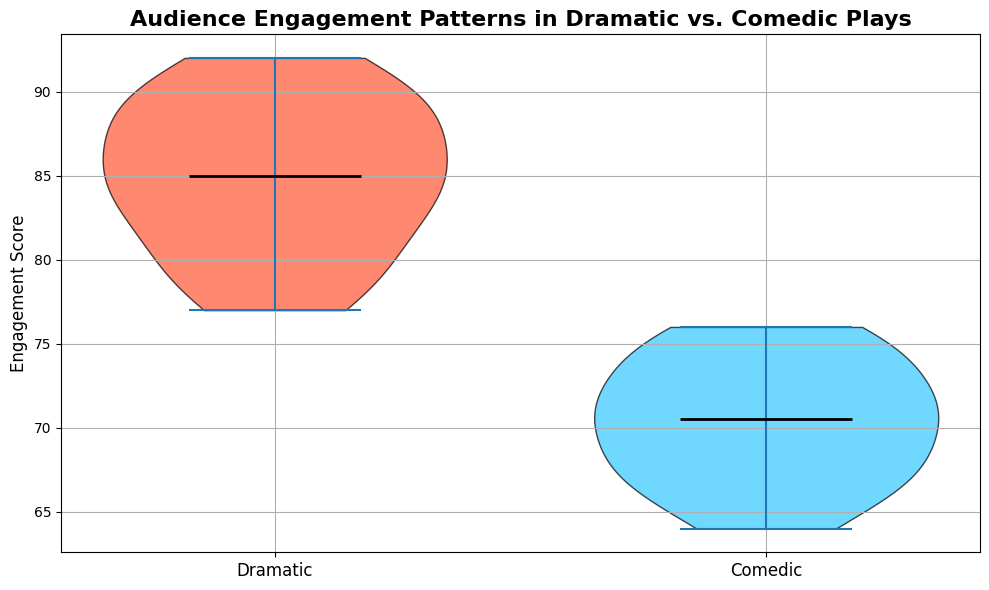Which play type has a higher median engagement score? The median is represented by the horizontal black line within the violin plot. The median for Dramatic plays is higher than the median for Comedic plays.
Answer: Dramatic What are the general ranges of engagement scores for both Dramatic and Comedic plays? The range can be observed from the lowest to the highest points within each violin. For Dramatic plays, it spans from about 77 to 92, while for Comedic plays, it spans from about 64 to 76.
Answer: Dramatic: 77-92, Comedic: 64-76 Are the engagement scores more spread out in Dramatic plays or Comedic plays? The spread can be determined by the width of each violin plot. The Dramatic plays' scores appear slightly more spread out as the violin is wider, indicating more variability within the scores.
Answer: Dramatic Which play type seems to have higher engagement scores overall? By visually comparing the position and density of the violins, we can see that the Dramatic plays tend to have higher engagement scores on average compared to Comedic plays.
Answer: Dramatic What are the central tendencies (most frequent values) for each play type? The thickness of each part of the violin plot indicates the density of the data points at that score. For Dramatic plays, central values appear around 84-85, while for Comedic plays, central values are around 71-72.
Answer: Dramatic: 84-85, Comedic: 71-72 Assuming a random audience score, which type of play is likely to gather an engagement score above 80? Looking at where most of the data points are concentrated, the Dramatic plays have a large portion of their violin plot above 80, whereas most of the Comedic play scores are below 80. Thus, Dramatic plays are more likely to gather a score above 80.
Answer: Dramatic In terms of visual representation, what colors are used to differentiate between Dramatic and Comedic plays? Dramatic plays are represented with a shade of red, and Comedic plays are represented with a shade of blue. These distinct colors help differentiate the two play types visually.
Answer: Red for Dramatic, Blue for Comedic 